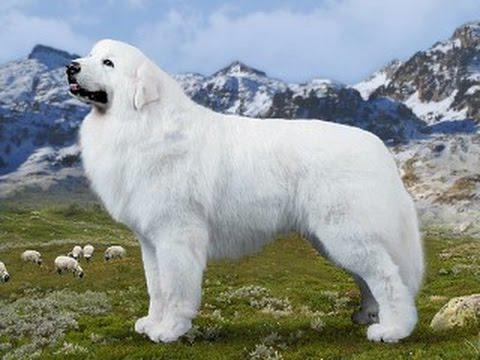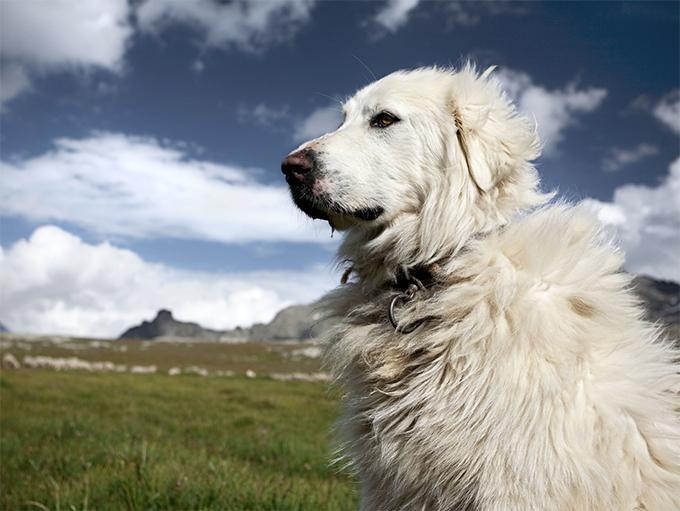The first image is the image on the left, the second image is the image on the right. Given the left and right images, does the statement "the right image has mountains in the background" hold true? Answer yes or no. Yes. The first image is the image on the left, the second image is the image on the right. Evaluate the accuracy of this statement regarding the images: "There is one dog facing right in the left image.". Is it true? Answer yes or no. No. 